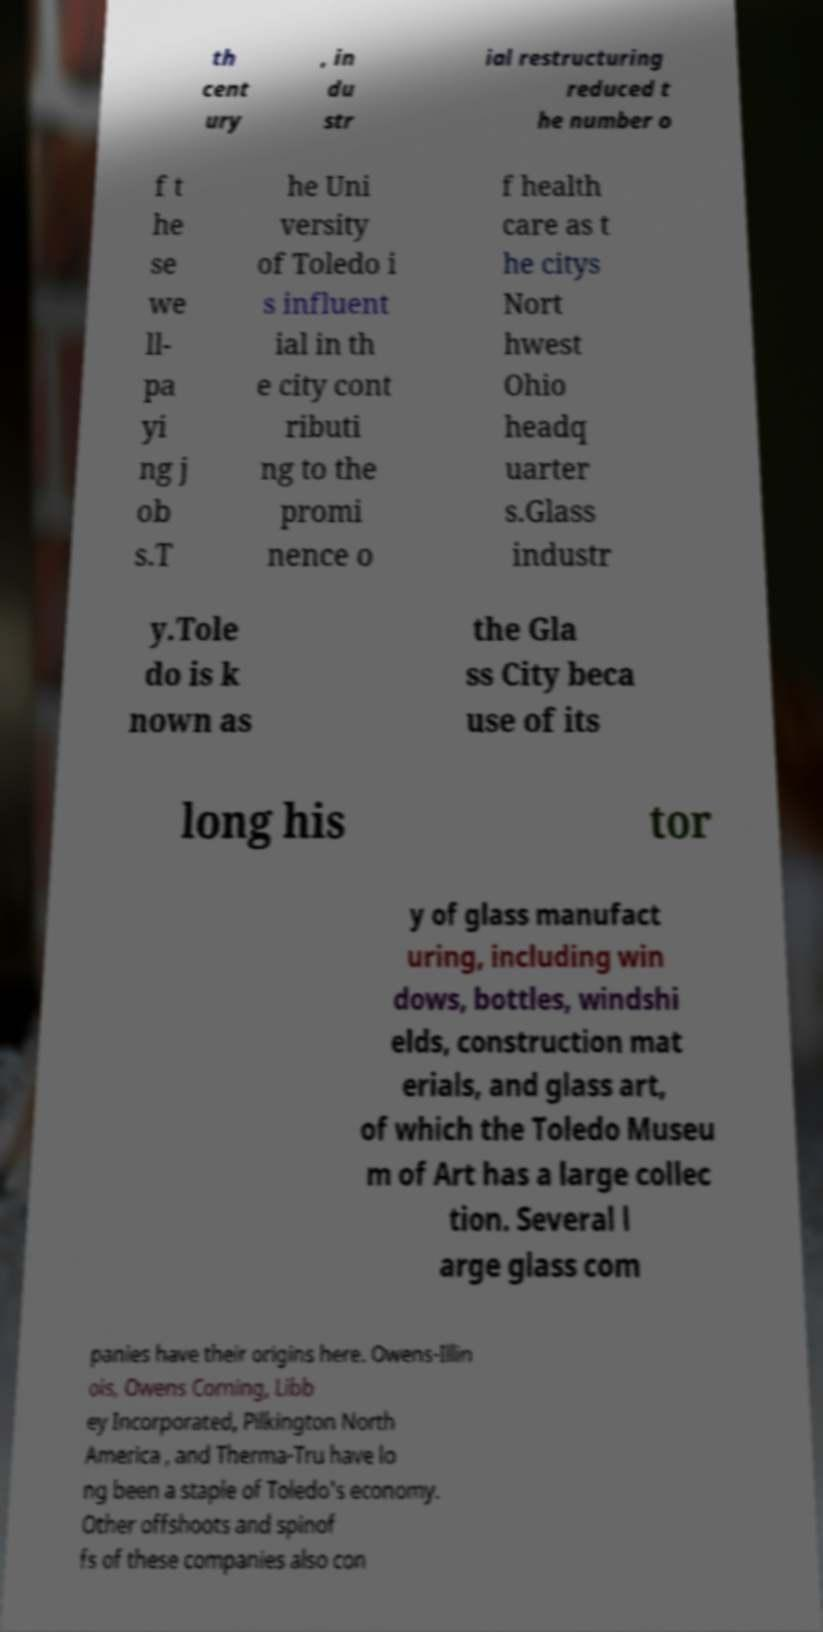Please read and relay the text visible in this image. What does it say? th cent ury , in du str ial restructuring reduced t he number o f t he se we ll- pa yi ng j ob s.T he Uni versity of Toledo i s influent ial in th e city cont ributi ng to the promi nence o f health care as t he citys Nort hwest Ohio headq uarter s.Glass industr y.Tole do is k nown as the Gla ss City beca use of its long his tor y of glass manufact uring, including win dows, bottles, windshi elds, construction mat erials, and glass art, of which the Toledo Museu m of Art has a large collec tion. Several l arge glass com panies have their origins here. Owens-Illin ois, Owens Corning, Libb ey Incorporated, Pilkington North America , and Therma-Tru have lo ng been a staple of Toledo's economy. Other offshoots and spinof fs of these companies also con 